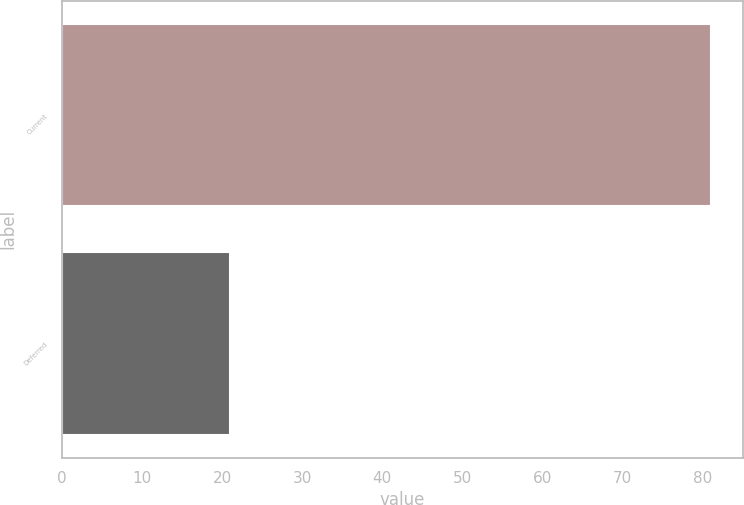<chart> <loc_0><loc_0><loc_500><loc_500><bar_chart><fcel>Current<fcel>Deferred<nl><fcel>81<fcel>21<nl></chart> 